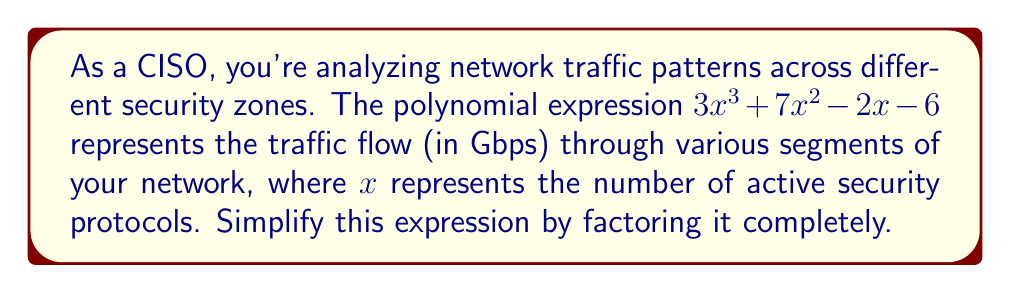Provide a solution to this math problem. Let's approach this step-by-step:

1) First, we need to check if there's a greatest common factor (GCF) for all terms. In this case, there isn't one.

2) Next, we can try to factor by grouping. Let's split the polynomial into two groups:

   $(3x^3 + 7x^2) + (-2x - 6)$

3) Factor out the common factor from each group:

   $x^2(3x + 7) - 2(x + 3)$

4) Now we can factor out $(x + 3)$ from both terms:

   $(x + 3)(3x^2 - 2)$

5) The second factor, $3x^2 - 2$, is a difference of squares if we factor out 3:

   $(x + 3)(3(x^2 - \frac{2}{3}))$

6) Rewrite the difference of squares:

   $(x + 3)(3(\sqrt{\frac{2}{3}}x + \sqrt{\frac{2}{3}})(\sqrt{\frac{2}{3}}x - \sqrt{\frac{2}{3}}))$

7) Simplify:

   $(x + 3)(\sqrt{6}x + \sqrt{6})(\sqrt{6}x - \sqrt{6})$

This is the fully factored form of the polynomial.
Answer: $(x + 3)(\sqrt{6}x + \sqrt{6})(\sqrt{6}x - \sqrt{6})$ 